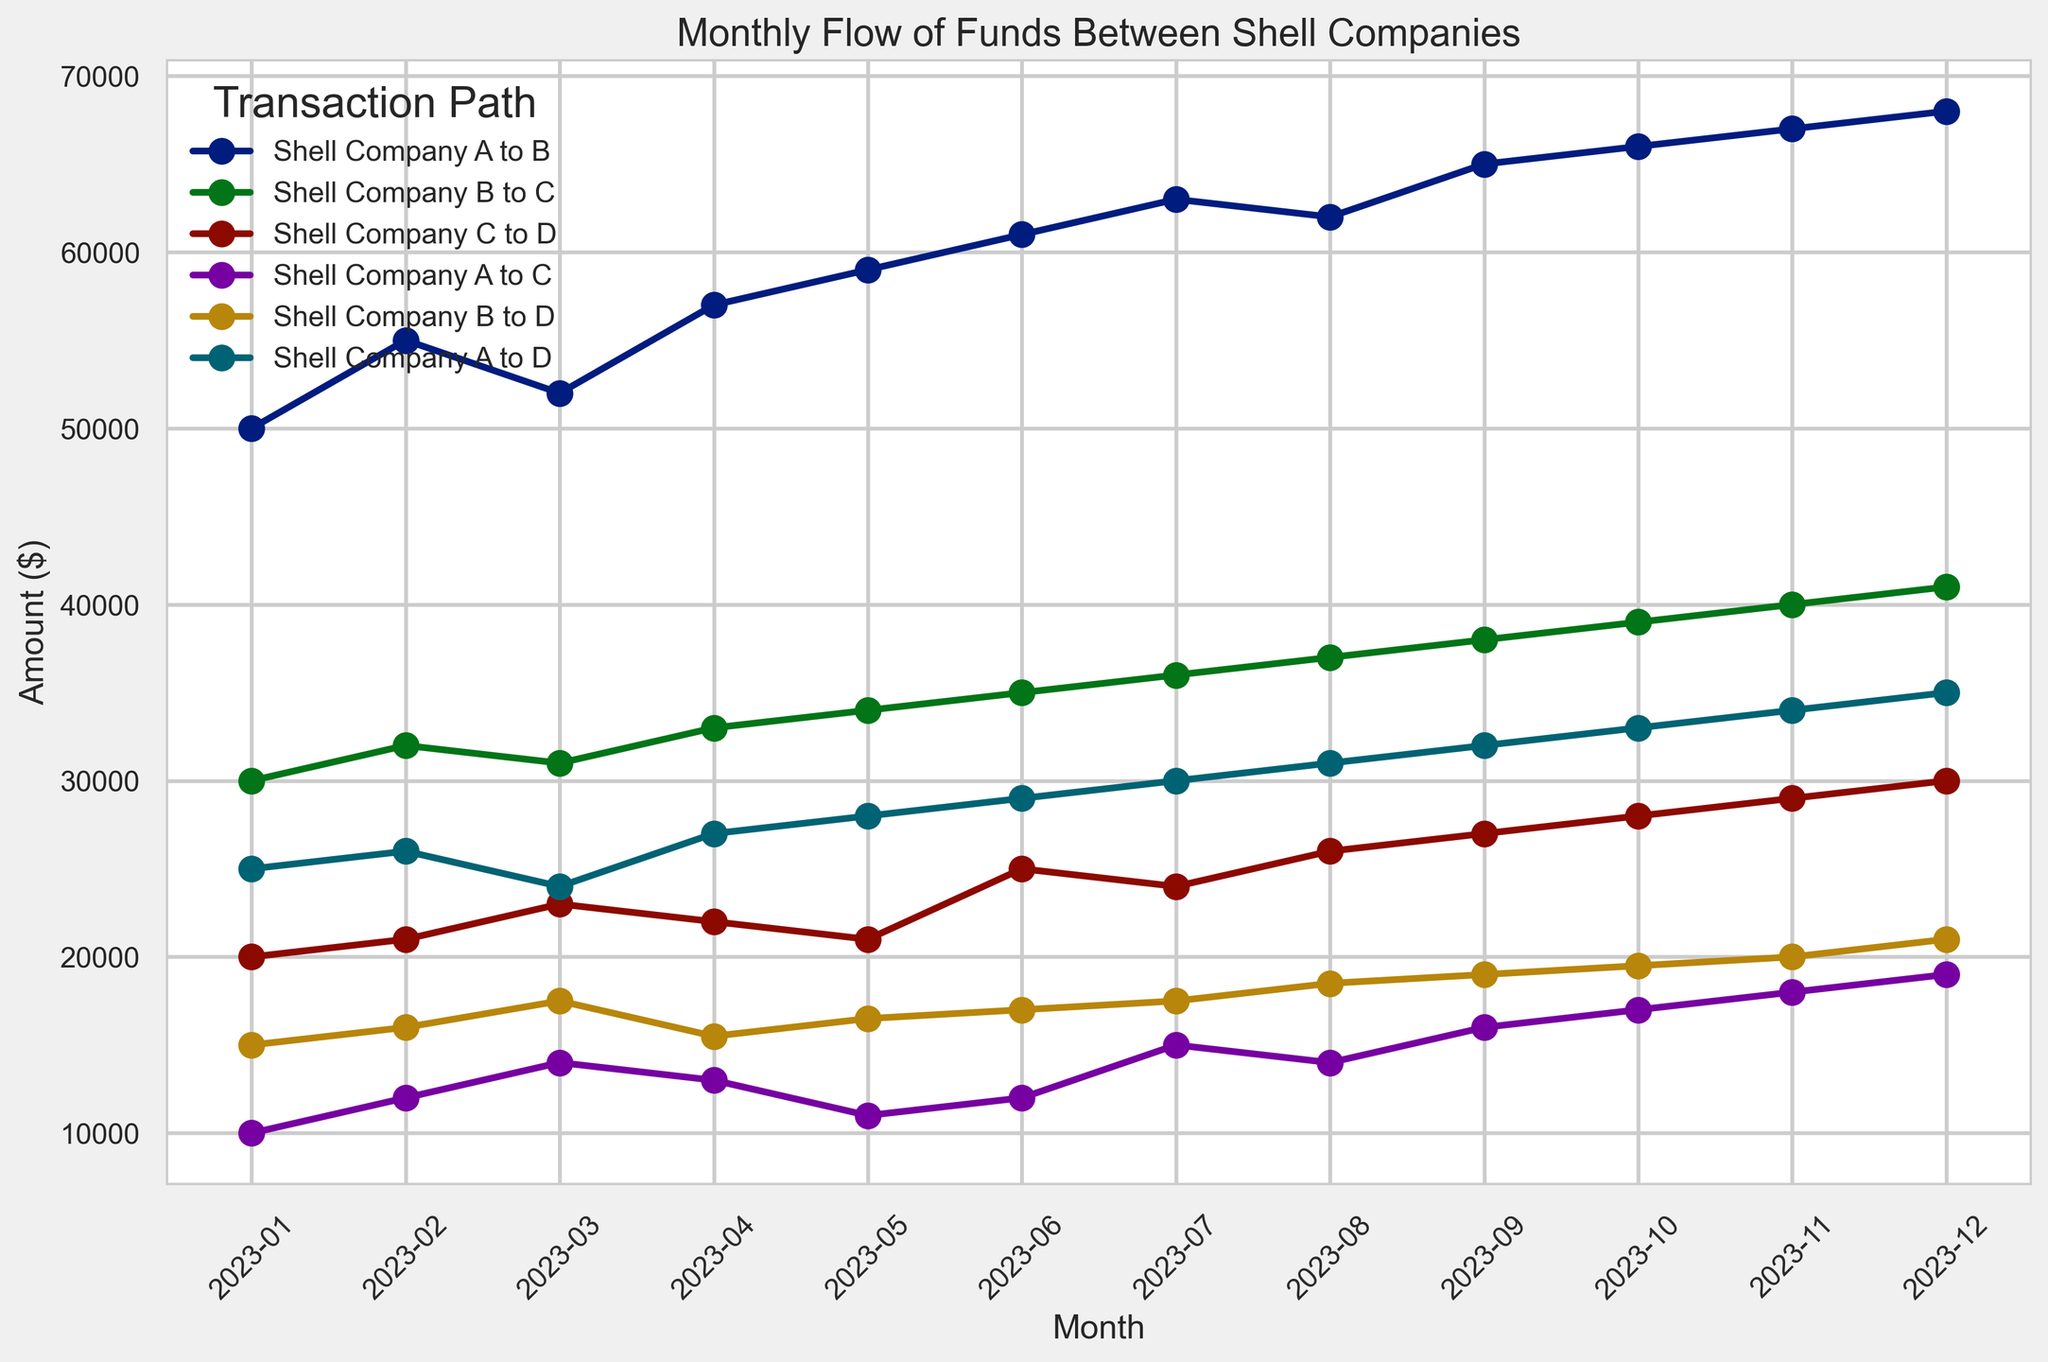Which month had the highest flow of funds from Shell Company A to B? By looking at the plot, identify the peak point on the line representing Shell Company A to B. This peak occurs where the y-value is highest. The highest flow from Shell Company A to B is at 68000 in December 2023.
Answer: December 2023 How does the flow of funds from Shell Company B to C compare between January and December 2023? Locate January and December on the plot and compare the y-values of the line corresponding to Shell Company B to C. In January 2023, the value is 30000, and in December 2023, it is 41000, showing an increase.
Answer: The flow in December is higher by 11000 During which month was the flow of funds from Shell Company C to D equal to the combined flow from Shell Company A to C and Shell Company B to D? Identify the month where the line for Shell Company C to D equals the combined values of Shell Company A to C and Shell Company B to D. In January 2023, Shell Company C to D is 20000, and the combined for Shell Company A to C (10000) and Shell Company B to D (15000) is 25000, so it exactly happens in March 2023 (23000 for C to D equals 14000 + 17500).
Answer: March 2023 What is the average flow of funds from Shell Company A to D over the year 2023? Compute the sum of the monthly values for Shell Company A to D and divide it by 12. (25000 + 26000 + 24000 + 27000 + 28000 + 29000 + 30000 + 31000 + 32000 + 33000 + 34000 + 35000) / 12 = 314000 / 12 = 26166.67.
Answer: 26166.67 Which transaction path has the most significant increase in the flow from January to December 2023? Identify the starting and ending values for each transaction path from January to December, then find the difference for each. Shell Company A to D shows an increase from 25000 to 35000, which is the most significant (10000).
Answer: Shell Company A to D Which month showed the lowest flow of funds from Shell Company B to D? Identify the lowest point on the line representing Shell Company B to D across the months. January 2023 had the lowest value of 15000.
Answer: January 2023 Compare the total flow of funds in April 2023 for all transaction paths combined with July 2023. Which month had a higher total flow? Sum all the transaction values for April and for July, then compare. April totals: 57000 + 33000 + 22000 + 13000 + 15500 + 27000 = 167500. July totals: 63000 + 36000 + 24000 + 15000 + 17500 + 30000 = 185500. July had a higher total by 18000.
Answer: July 2023 